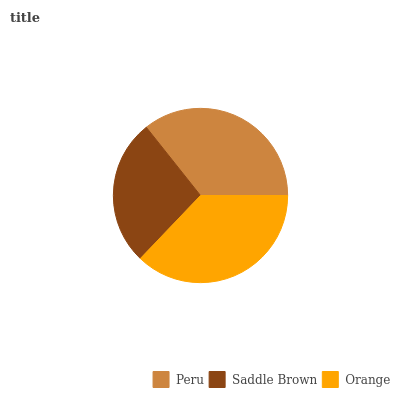Is Saddle Brown the minimum?
Answer yes or no. Yes. Is Orange the maximum?
Answer yes or no. Yes. Is Orange the minimum?
Answer yes or no. No. Is Saddle Brown the maximum?
Answer yes or no. No. Is Orange greater than Saddle Brown?
Answer yes or no. Yes. Is Saddle Brown less than Orange?
Answer yes or no. Yes. Is Saddle Brown greater than Orange?
Answer yes or no. No. Is Orange less than Saddle Brown?
Answer yes or no. No. Is Peru the high median?
Answer yes or no. Yes. Is Peru the low median?
Answer yes or no. Yes. Is Orange the high median?
Answer yes or no. No. Is Saddle Brown the low median?
Answer yes or no. No. 